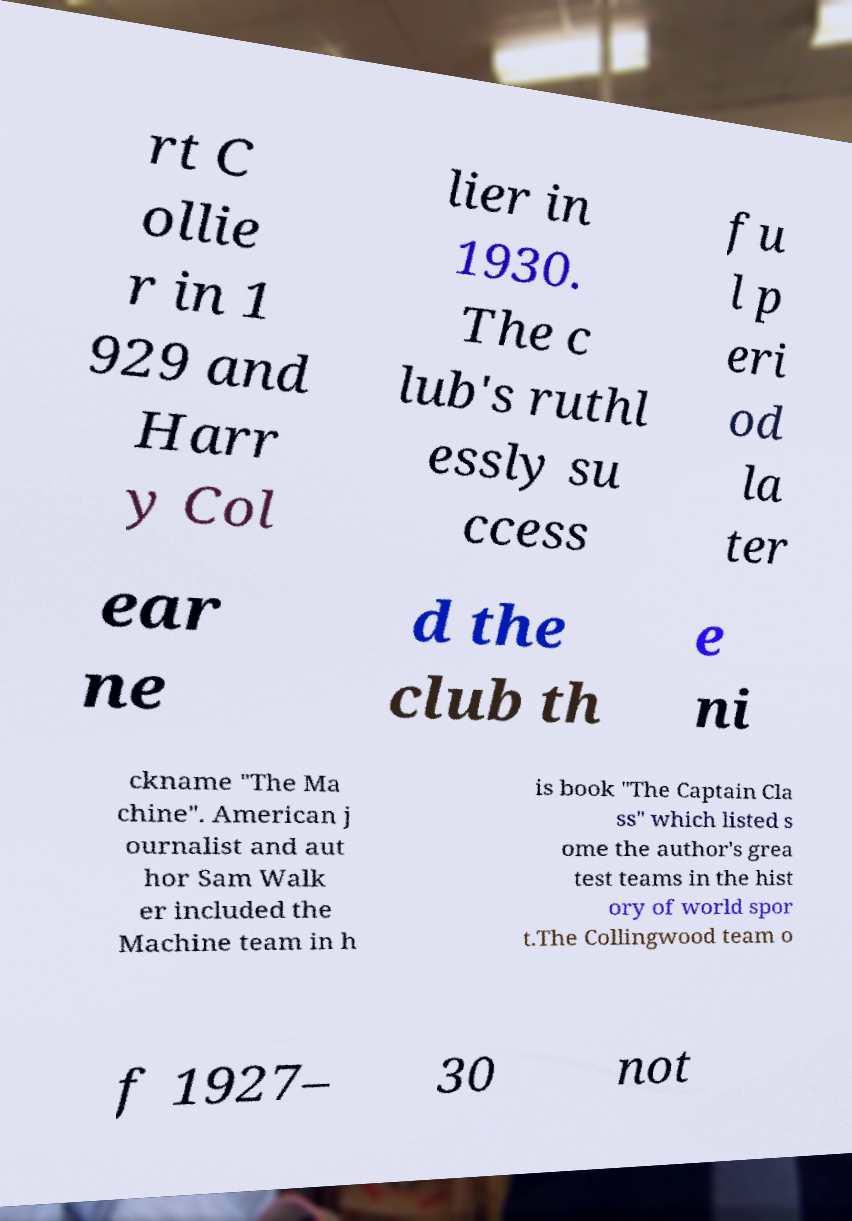Could you extract and type out the text from this image? rt C ollie r in 1 929 and Harr y Col lier in 1930. The c lub's ruthl essly su ccess fu l p eri od la ter ear ne d the club th e ni ckname "The Ma chine". American j ournalist and aut hor Sam Walk er included the Machine team in h is book "The Captain Cla ss" which listed s ome the author's grea test teams in the hist ory of world spor t.The Collingwood team o f 1927– 30 not 